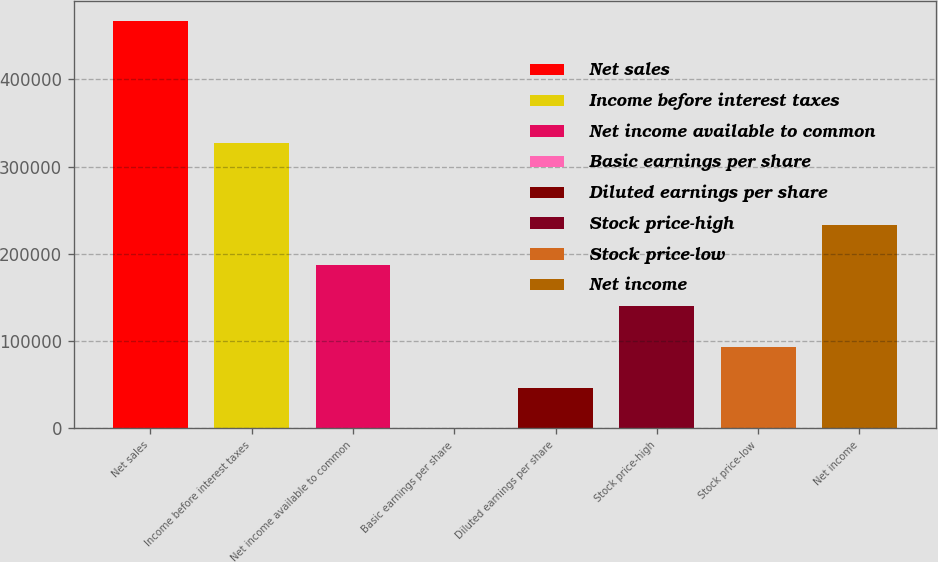Convert chart. <chart><loc_0><loc_0><loc_500><loc_500><bar_chart><fcel>Net sales<fcel>Income before interest taxes<fcel>Net income available to common<fcel>Basic earnings per share<fcel>Diluted earnings per share<fcel>Stock price-high<fcel>Stock price-low<fcel>Net income<nl><fcel>466964<fcel>326875<fcel>186786<fcel>0.29<fcel>46696.7<fcel>140089<fcel>93393<fcel>233482<nl></chart> 